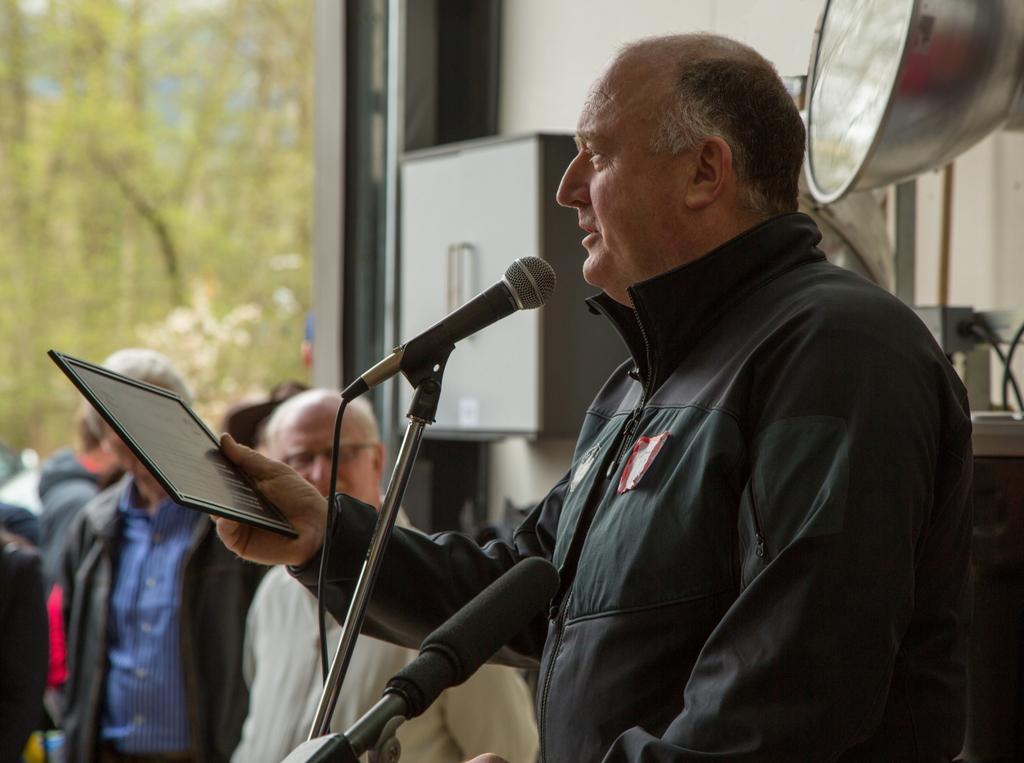How would you summarize this image in a sentence or two? In this picture there is a man on the right side of the image, by holding a small board in his hand and there are mics in front of him and there are other men on the left side of the image, there is a glass window on the left side of the image and there are trees outside the window. 